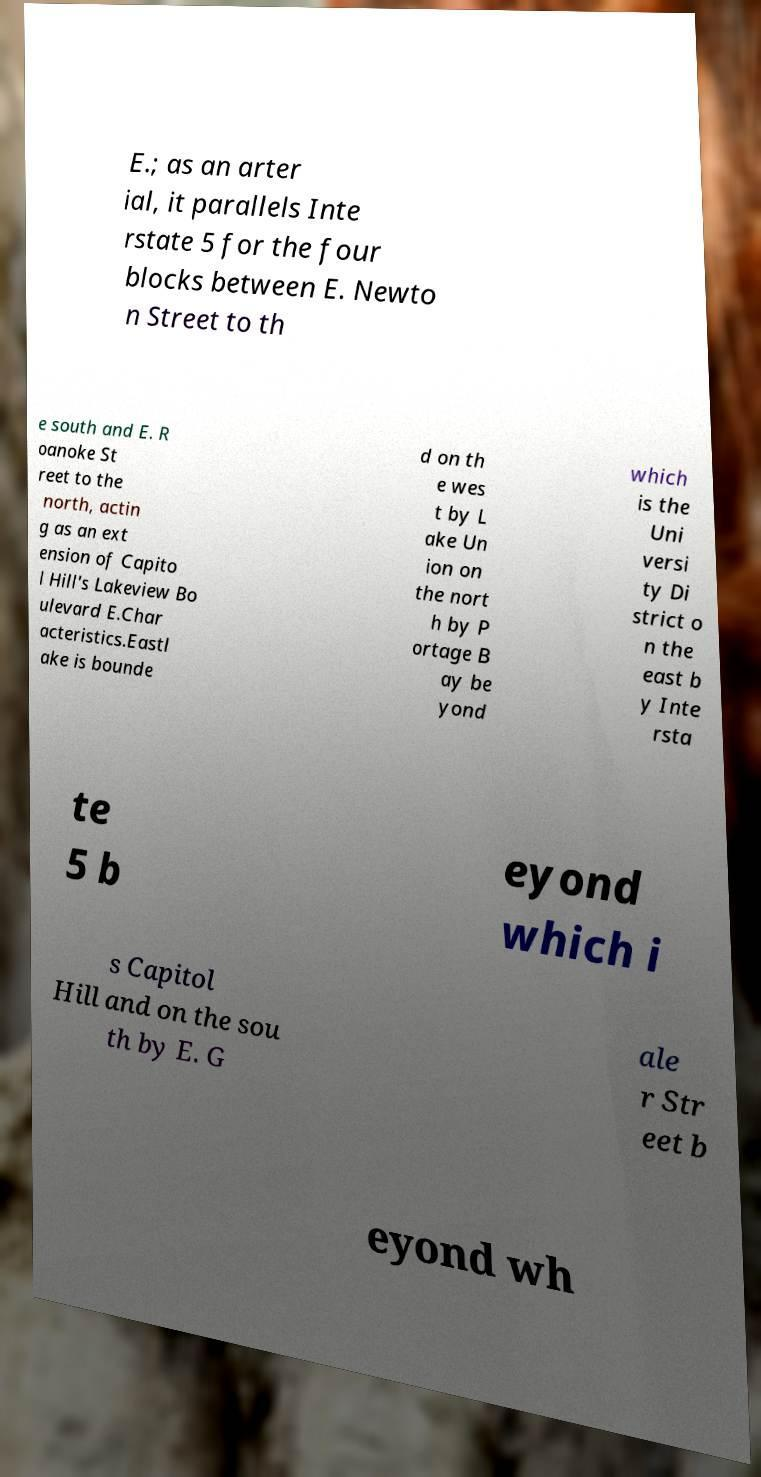Could you extract and type out the text from this image? E.; as an arter ial, it parallels Inte rstate 5 for the four blocks between E. Newto n Street to th e south and E. R oanoke St reet to the north, actin g as an ext ension of Capito l Hill's Lakeview Bo ulevard E.Char acteristics.Eastl ake is bounde d on th e wes t by L ake Un ion on the nort h by P ortage B ay be yond which is the Uni versi ty Di strict o n the east b y Inte rsta te 5 b eyond which i s Capitol Hill and on the sou th by E. G ale r Str eet b eyond wh 